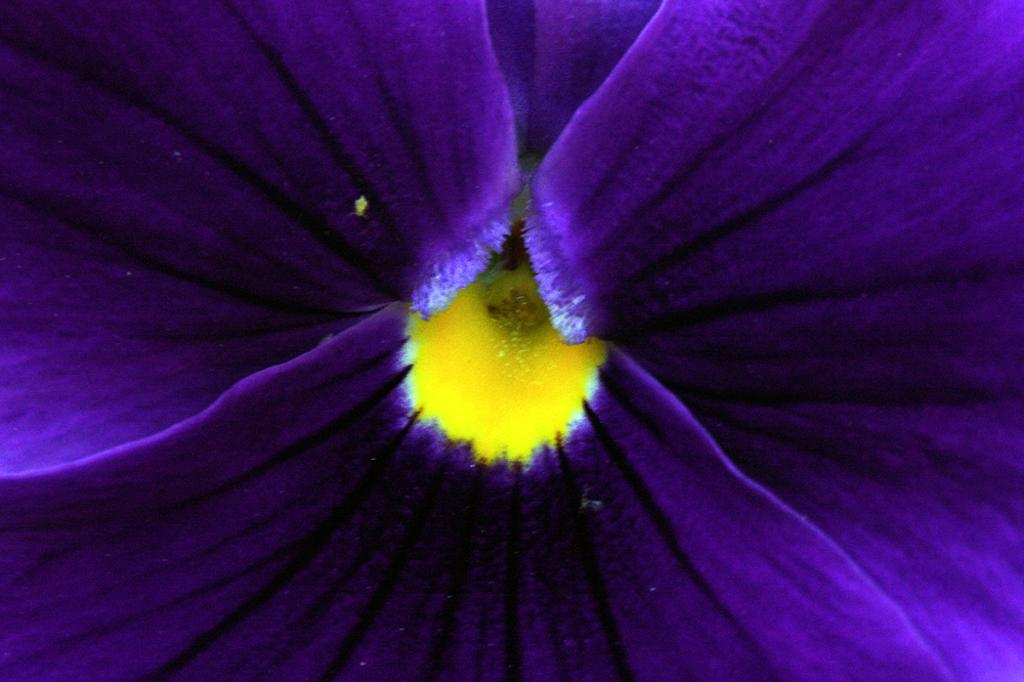What is the main subject of the picture? The main subject of the picture is a flower. What color are the petals of the flower? The petals of the flower have a purple color. What type of pen is the girl using to write a note to her partner in the image? There is no girl, pen, or note present in the image; it only features a flower with purple petals. 